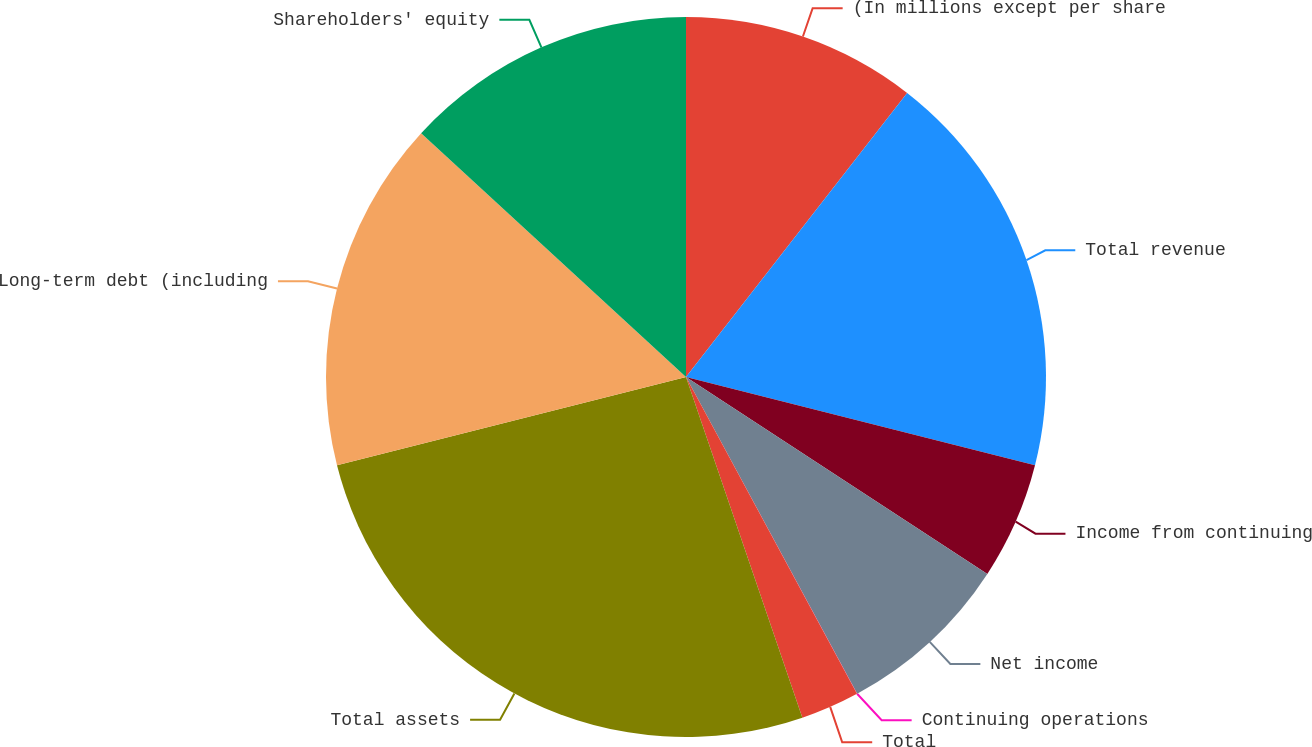Convert chart to OTSL. <chart><loc_0><loc_0><loc_500><loc_500><pie_chart><fcel>(In millions except per share<fcel>Total revenue<fcel>Income from continuing<fcel>Net income<fcel>Continuing operations<fcel>Total<fcel>Total assets<fcel>Long-term debt (including<fcel>Shareholders' equity<nl><fcel>10.53%<fcel>18.42%<fcel>5.27%<fcel>7.9%<fcel>0.01%<fcel>2.64%<fcel>26.3%<fcel>15.79%<fcel>13.16%<nl></chart> 